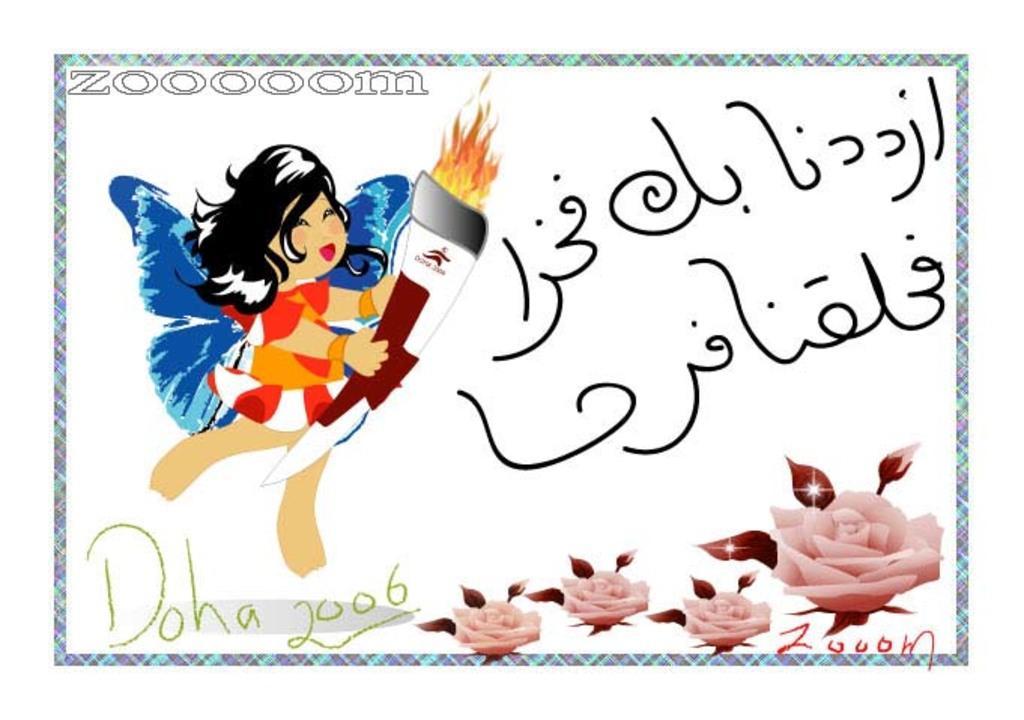How would you summarize this image in a sentence or two? In this image, we can see a cartoon, flowers and some text. 